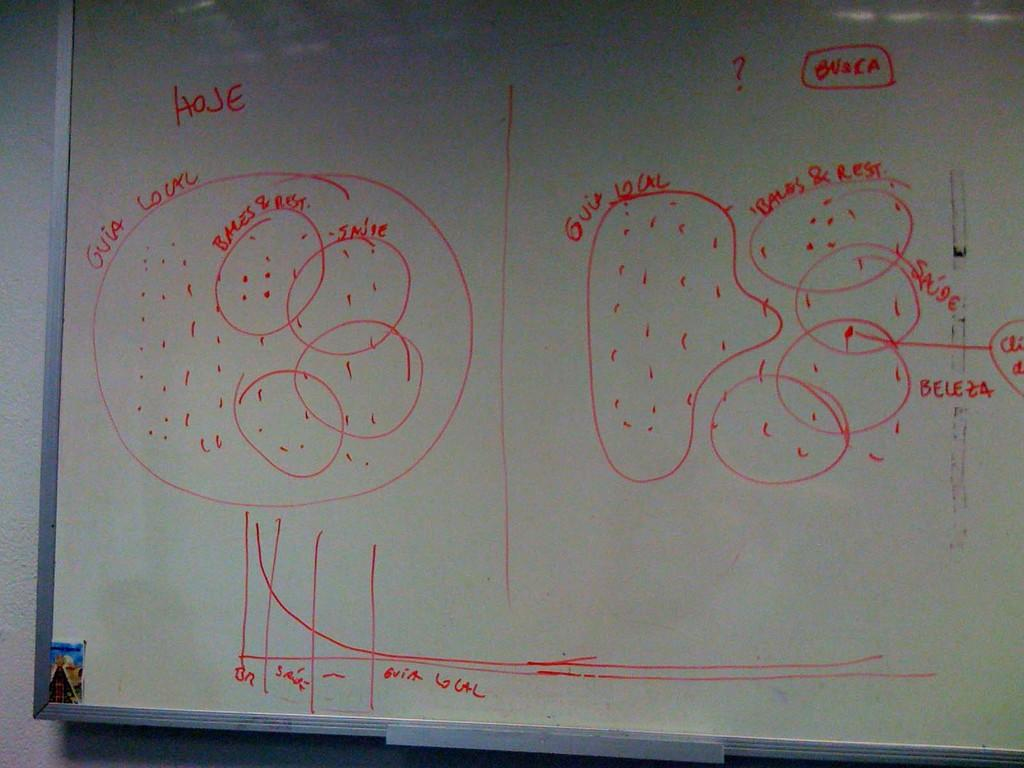<image>
Offer a succinct explanation of the picture presented. White board that says the word "HOJE" on the left. 